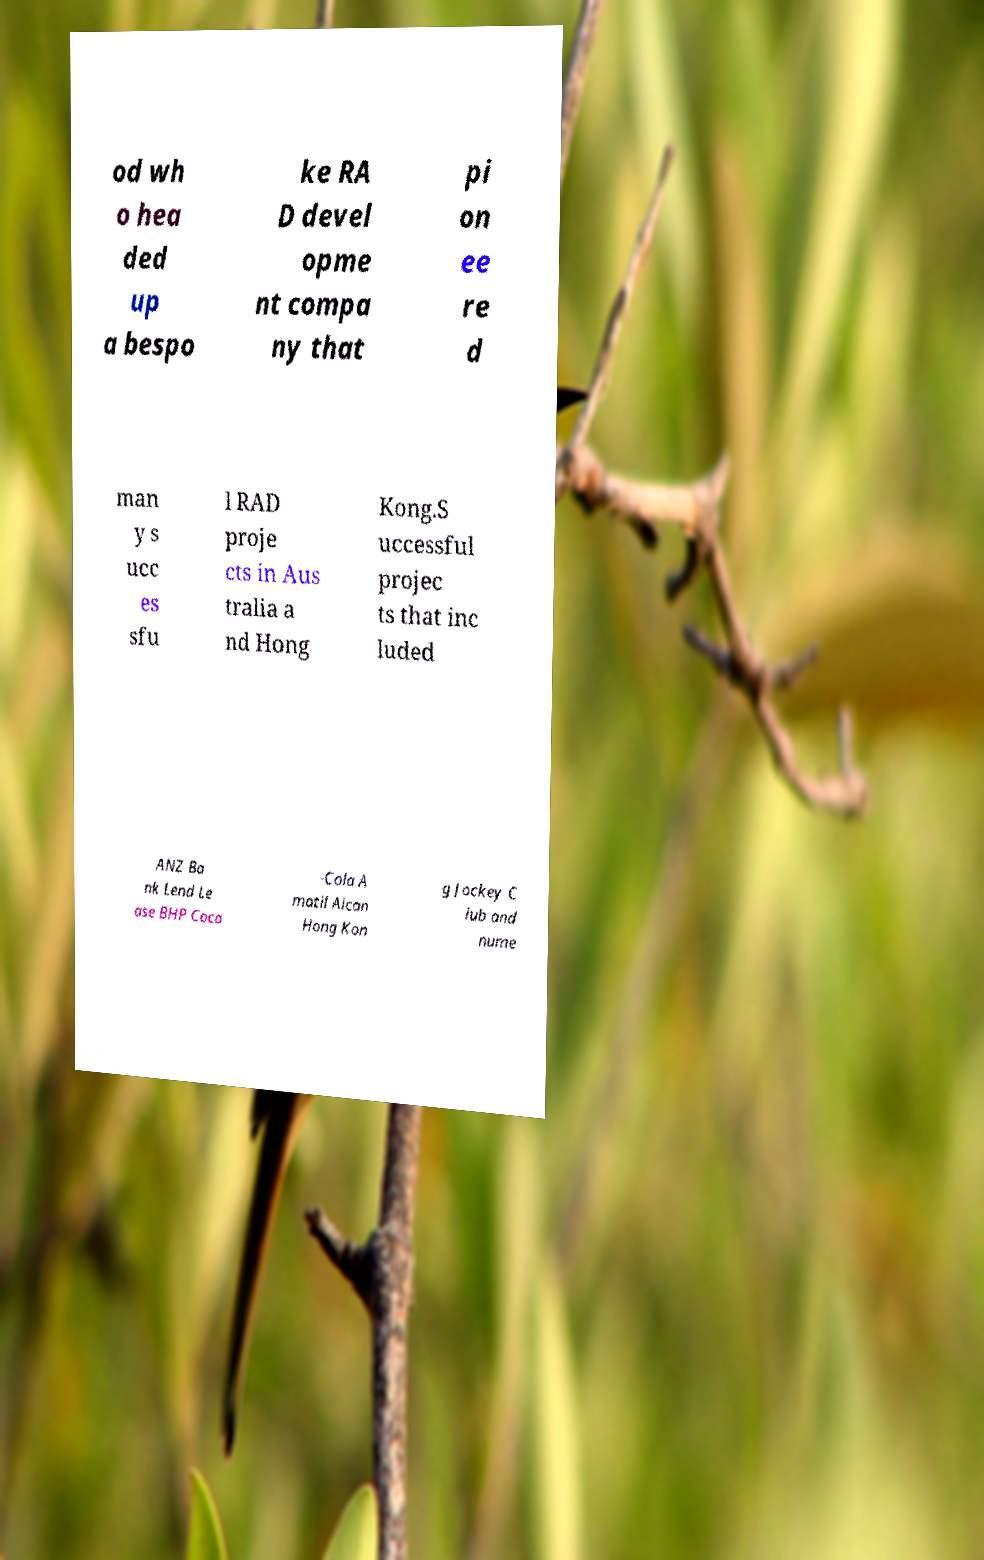Can you read and provide the text displayed in the image?This photo seems to have some interesting text. Can you extract and type it out for me? od wh o hea ded up a bespo ke RA D devel opme nt compa ny that pi on ee re d man y s ucc es sfu l RAD proje cts in Aus tralia a nd Hong Kong.S uccessful projec ts that inc luded ANZ Ba nk Lend Le ase BHP Coca -Cola A matil Alcan Hong Kon g Jockey C lub and nume 